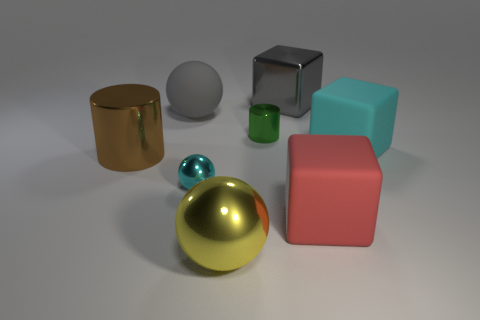Subtract all large balls. How many balls are left? 1 Subtract 1 balls. How many balls are left? 2 Subtract all purple blocks. Subtract all yellow balls. How many blocks are left? 3 Add 1 cyan shiny spheres. How many objects exist? 9 Subtract all spheres. How many objects are left? 5 Add 1 tiny blue blocks. How many tiny blue blocks exist? 1 Subtract 0 cyan cylinders. How many objects are left? 8 Subtract all big matte things. Subtract all large rubber cylinders. How many objects are left? 5 Add 2 large cyan matte cubes. How many large cyan matte cubes are left? 3 